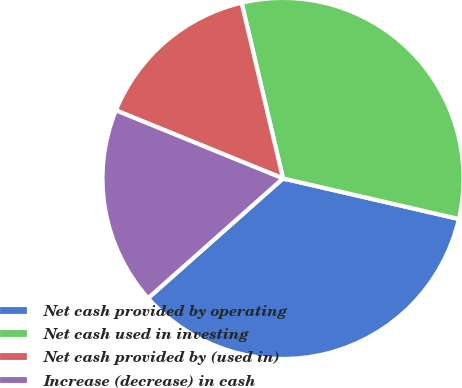Convert chart. <chart><loc_0><loc_0><loc_500><loc_500><pie_chart><fcel>Net cash provided by operating<fcel>Net cash used in investing<fcel>Net cash provided by (used in)<fcel>Increase (decrease) in cash<nl><fcel>34.84%<fcel>32.29%<fcel>15.16%<fcel>17.71%<nl></chart> 